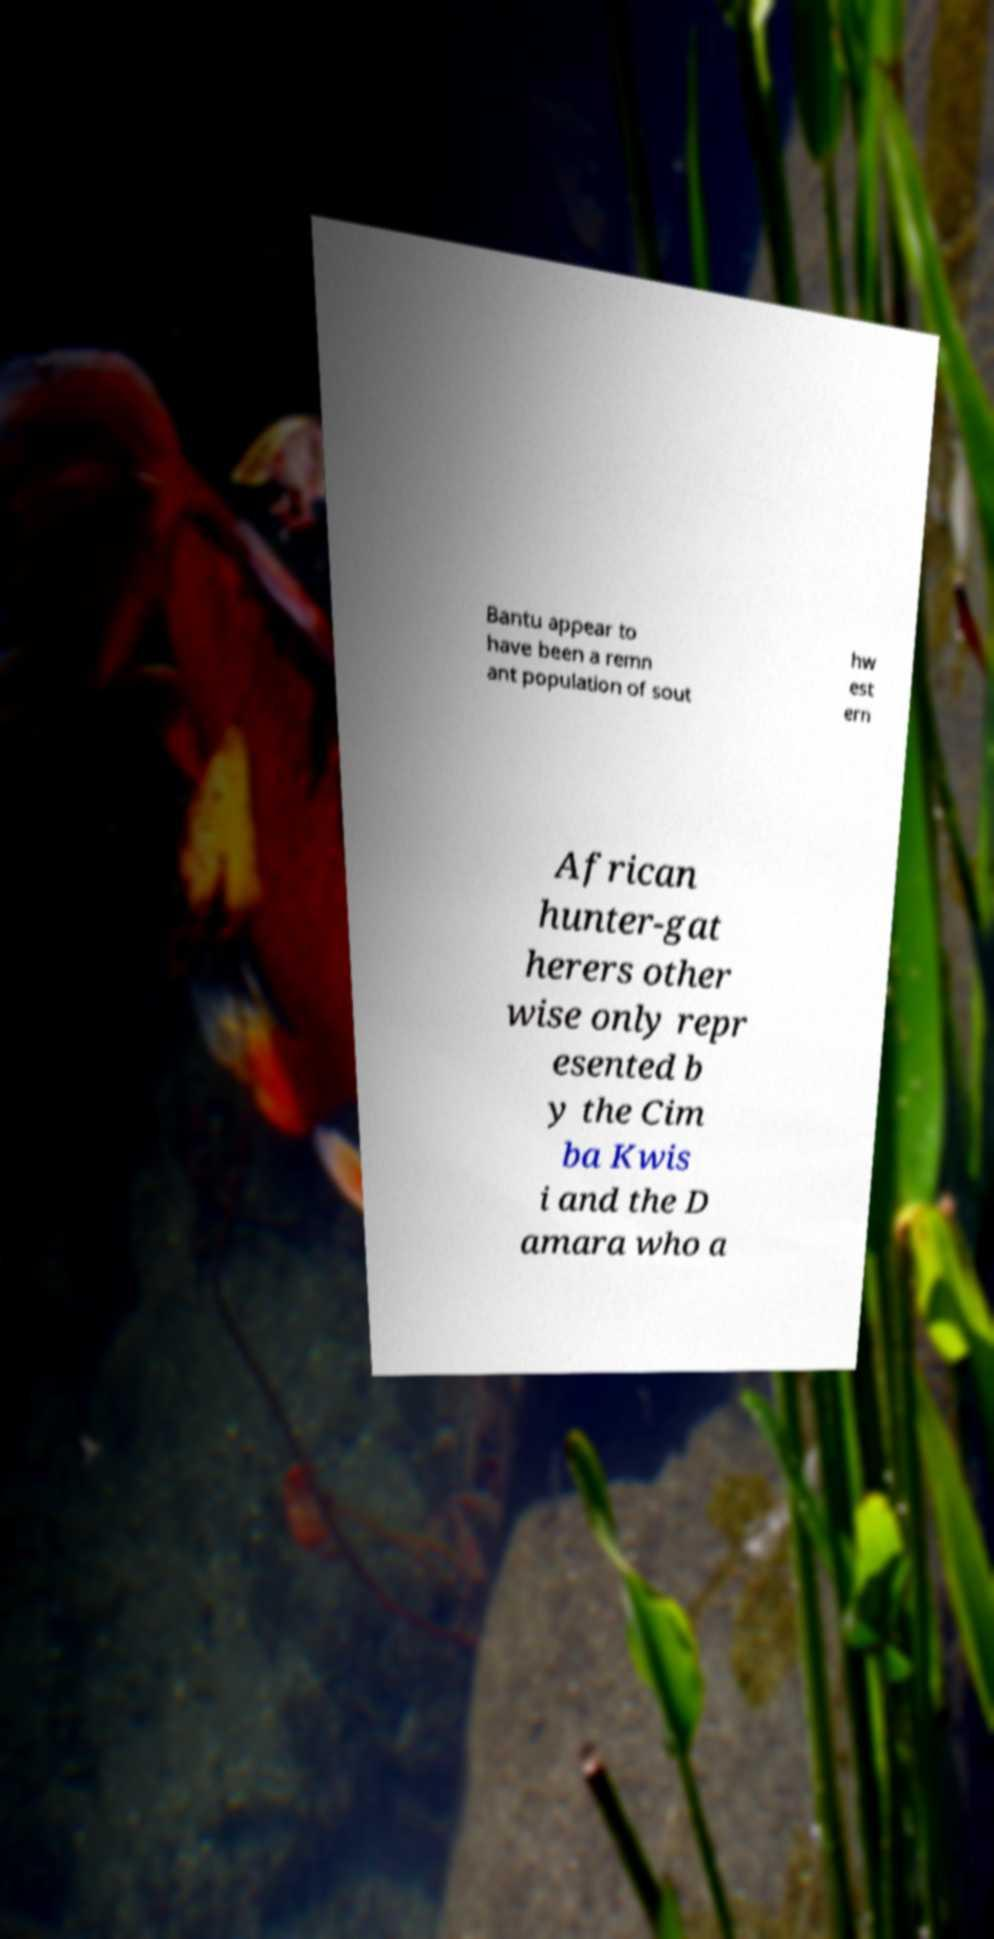Please identify and transcribe the text found in this image. Bantu appear to have been a remn ant population of sout hw est ern African hunter-gat herers other wise only repr esented b y the Cim ba Kwis i and the D amara who a 